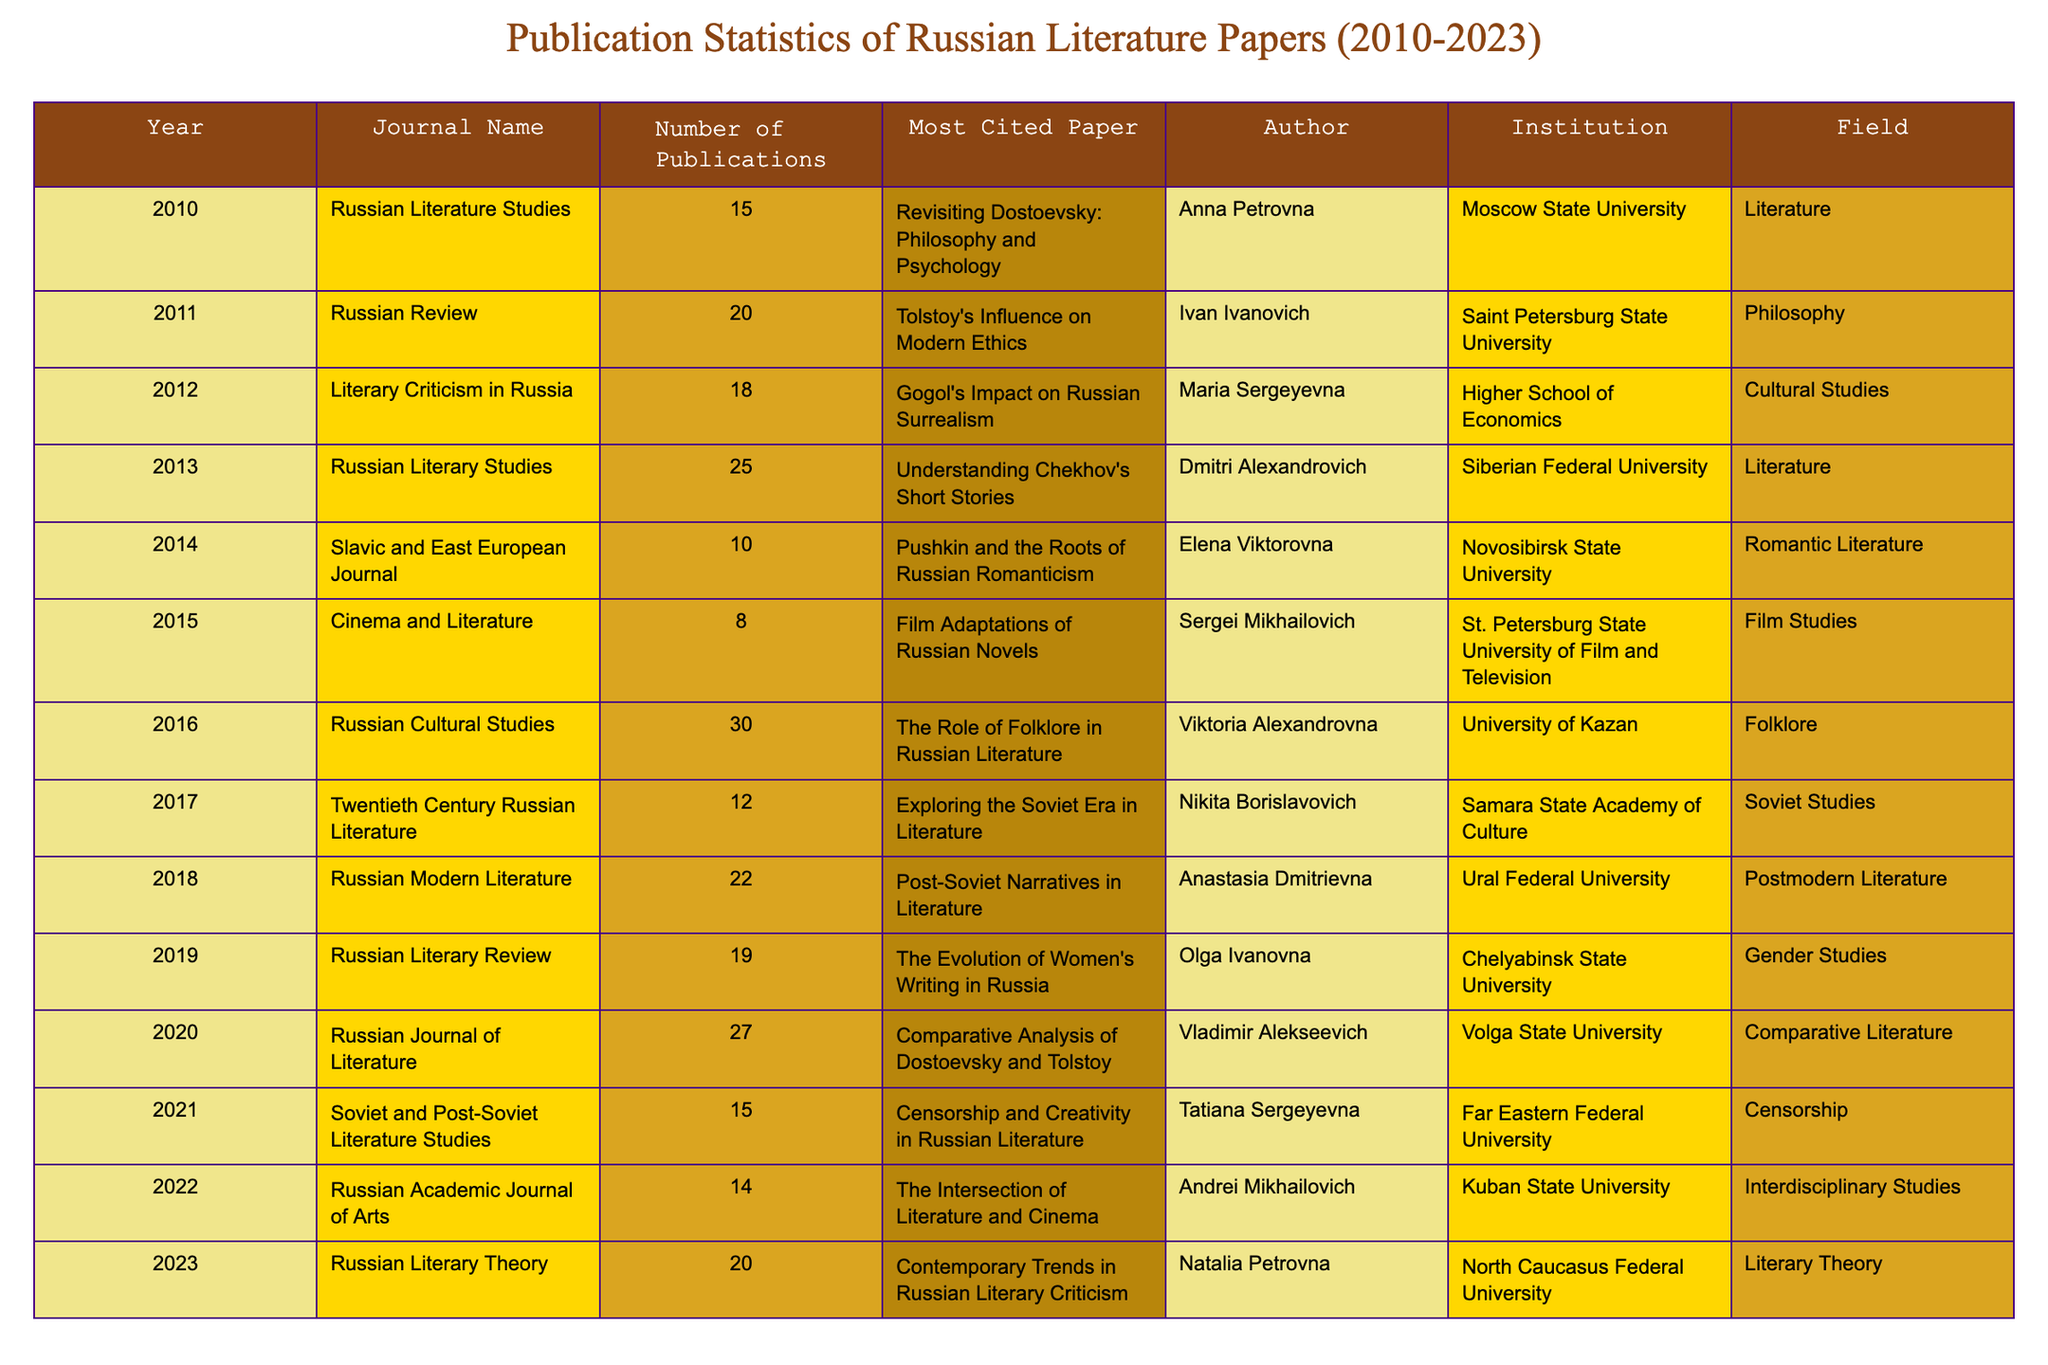What was the year with the highest number of publications? By scanning through the "Number of Publications" column, I see that the year 2016 has the highest count at 30 publications.
Answer: 2016 Which journal published fewer than 15 papers in 2015? According to the table, "Cinema and Literature" published 8 papers in 2015, which is fewer than 15.
Answer: Yes How many total publications were made in the year 2020 and 2021 combined? To find the total publications for 2020 and 2021, I sum the publications: 27 (2020) + 15 (2021) = 42.
Answer: 42 In which field was the most cited paper of the year 2013 published? The most cited paper in 2013 was "Understanding Chekhov's Short Stories," and it falls under the "Literature" field as indicated in the table.
Answer: Literature Was there any year in which publications exceeded 25? I check each year's publication count, and yes, the years 2013 (25), 2016 (30), and 2020 (27) had more than 25 publications.
Answer: Yes What is the average number of publications per year over the years listed in the table? The total number of publications from 2010 to 2023 is 224, and there are 14 years. I divide 224 by 14 to get an average of 16.
Answer: 16 Which author had a publication in a journal focused on Film Studies? The table shows that Sergei Mikhailovich published in "Cinema and Literature," which is focused on Film Studies in 2015.
Answer: Sergei Mikhailovich Compare the total number of publications between the years 2018 and 2019. Which year had more? In 2018, there were 22 publications, while in 2019, there were 19. Thus, 2018 had more publications than 2019.
Answer: 2018 What was the most cited paper in the year 2022 and which institution was it associated with? The most cited paper in 2022 is "The Intersection of Literature and Cinema," and it is associated with Kuban State University.
Answer: "The Intersection of Literature and Cinema", Kuban State University 